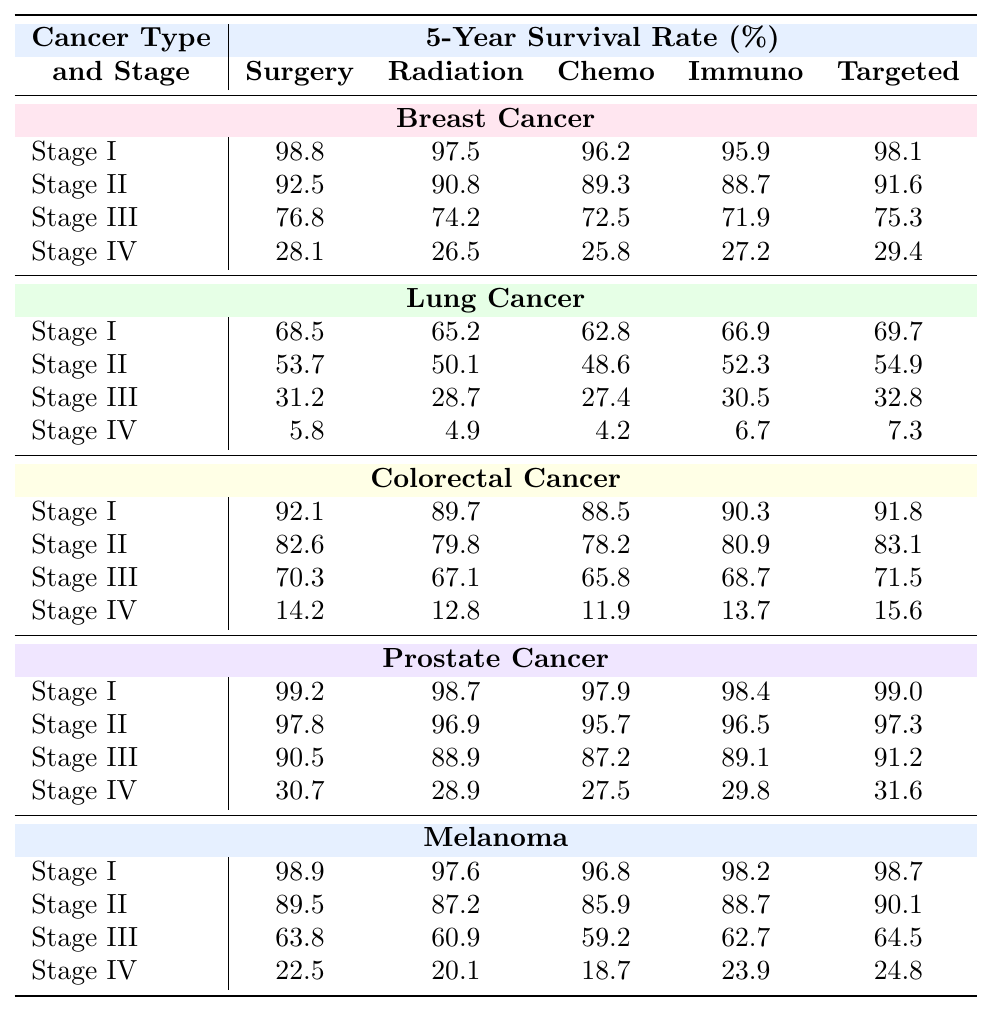What is the 5-year survival rate for Surgery in Stage I Breast Cancer? From the table, under the Breast Cancer section, for Stage I, the 5-year survival rate for Surgery is listed as 98.8%.
Answer: 98.8% Which treatment has the highest survival rate for Stage IV Colorectal Cancer? Checking the survival rates under the Colorectal Cancer section for Stage IV, the survival rates are: Surgery 14.2%, Radiation Therapy 12.8%, Chemotherapy 11.9%, Immunotherapy 13.7%, and Targeted Therapy 15.6%. Targeted Therapy has the highest rate at 15.6%.
Answer: Targeted Therapy What is the average 5-year survival rate for Immunotherapy across all stages of Lung Cancer? Looking at the Lung Cancer section, the survival rates for Immunotherapy are: Stage I 66.9%, Stage II 52.3%, Stage III 30.5%, and Stage IV 6.7%. Adding these rates gives 66.9 + 52.3 + 30.5 + 6.7 = 156.4. Dividing by 4 (the number of stages) gives an average of 39.1%.
Answer: 39.1% Is the 5-year survival rate for Chemotherapy in Stage III Melanoma greater than 60%? According to the table, the survival rate for Chemotherapy in Stage III Melanoma is given as 59.2%. Since 59.2% is less than 60%, the answer is no.
Answer: No What is the difference in 5-year survival rates for Surgery between Stage I and Stage IV Prostate Cancer? From the Prostate Cancer section, the 5-year survival rate for Surgery in Stage I is 99.2%, while in Stage IV it is 30.7%. The difference is calculated by subtracting: 99.2 - 30.7 = 68.5%.
Answer: 68.5% Which cancer treatment has the lowest survival rate in Stage III for any type of cancer? Reviewing Stage III survival rates across all cancer types, the lowest rates are: Breast Cancer (Surgery 76.8%), Lung Cancer (Chemotherapy 27.4%), Colorectal Cancer (Chemotherapy 65.8%), Prostate Cancer (Chemotherapy 87.2%), and Melanoma (Chemotherapy 59.2%). The lowest is for Lung Cancer Chemotherapy at 27.4%.
Answer: 27.4% For Stage II Melanoma, what is the difference between the survival rates of Surgery and Targeted Therapy? The table indicates that for Stage II Melanoma, the survival rate for Surgery is 89.5% and for Targeted Therapy it's 90.1%. The difference is 90.1 - 89.5 = 0.6%.
Answer: 0.6% Do patients with Stage I Lung Cancer who undergo Immunotherapy have a better survival rate than those in Stage II who undergo Radiation Therapy? The survival rate for Lung Cancer Stage I Immunotherapy is 66.9%, while for Stage II Radiation Therapy it is 50.1%. Since 66.9% is greater than 50.1%, the answer is yes.
Answer: Yes What treatment gives the lowest 5-year survival rate in Stage IV for Breast Cancer? In the Breast Cancer section for Stage IV, the survival rates for various treatments are: Surgery 28.1%, Radiation Therapy 26.5%, Chemotherapy 25.8%, Immunotherapy 27.2%, and Targeted Therapy 29.4%. The lowest rate is for Chemotherapy at 25.8%.
Answer: Chemotherapy 